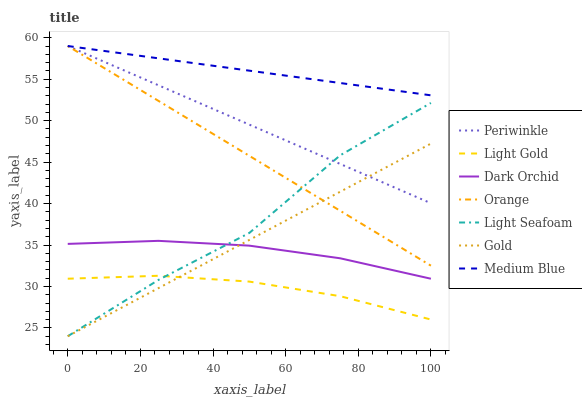Does Light Gold have the minimum area under the curve?
Answer yes or no. Yes. Does Medium Blue have the maximum area under the curve?
Answer yes or no. Yes. Does Dark Orchid have the minimum area under the curve?
Answer yes or no. No. Does Dark Orchid have the maximum area under the curve?
Answer yes or no. No. Is Periwinkle the smoothest?
Answer yes or no. Yes. Is Light Seafoam the roughest?
Answer yes or no. Yes. Is Medium Blue the smoothest?
Answer yes or no. No. Is Medium Blue the roughest?
Answer yes or no. No. Does Gold have the lowest value?
Answer yes or no. Yes. Does Dark Orchid have the lowest value?
Answer yes or no. No. Does Orange have the highest value?
Answer yes or no. Yes. Does Dark Orchid have the highest value?
Answer yes or no. No. Is Light Gold less than Dark Orchid?
Answer yes or no. Yes. Is Orange greater than Dark Orchid?
Answer yes or no. Yes. Does Periwinkle intersect Orange?
Answer yes or no. Yes. Is Periwinkle less than Orange?
Answer yes or no. No. Is Periwinkle greater than Orange?
Answer yes or no. No. Does Light Gold intersect Dark Orchid?
Answer yes or no. No. 